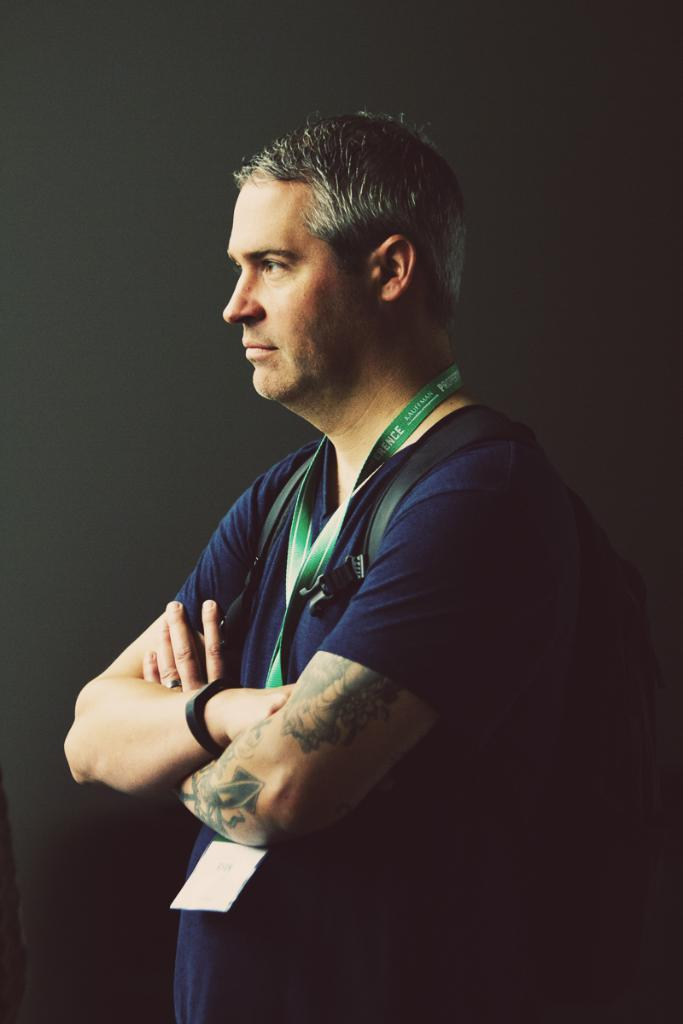What is the main subject of the image? There is a person in the image. What is the person wearing in the image? The person is wearing a bag. What type of quill is the person holding in the image? There is no quill present in the image. How many quarters can be seen in the image? There are no quarters visible in the image. 